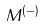Convert formula to latex. <formula><loc_0><loc_0><loc_500><loc_500>M ^ { ( - ) }</formula> 